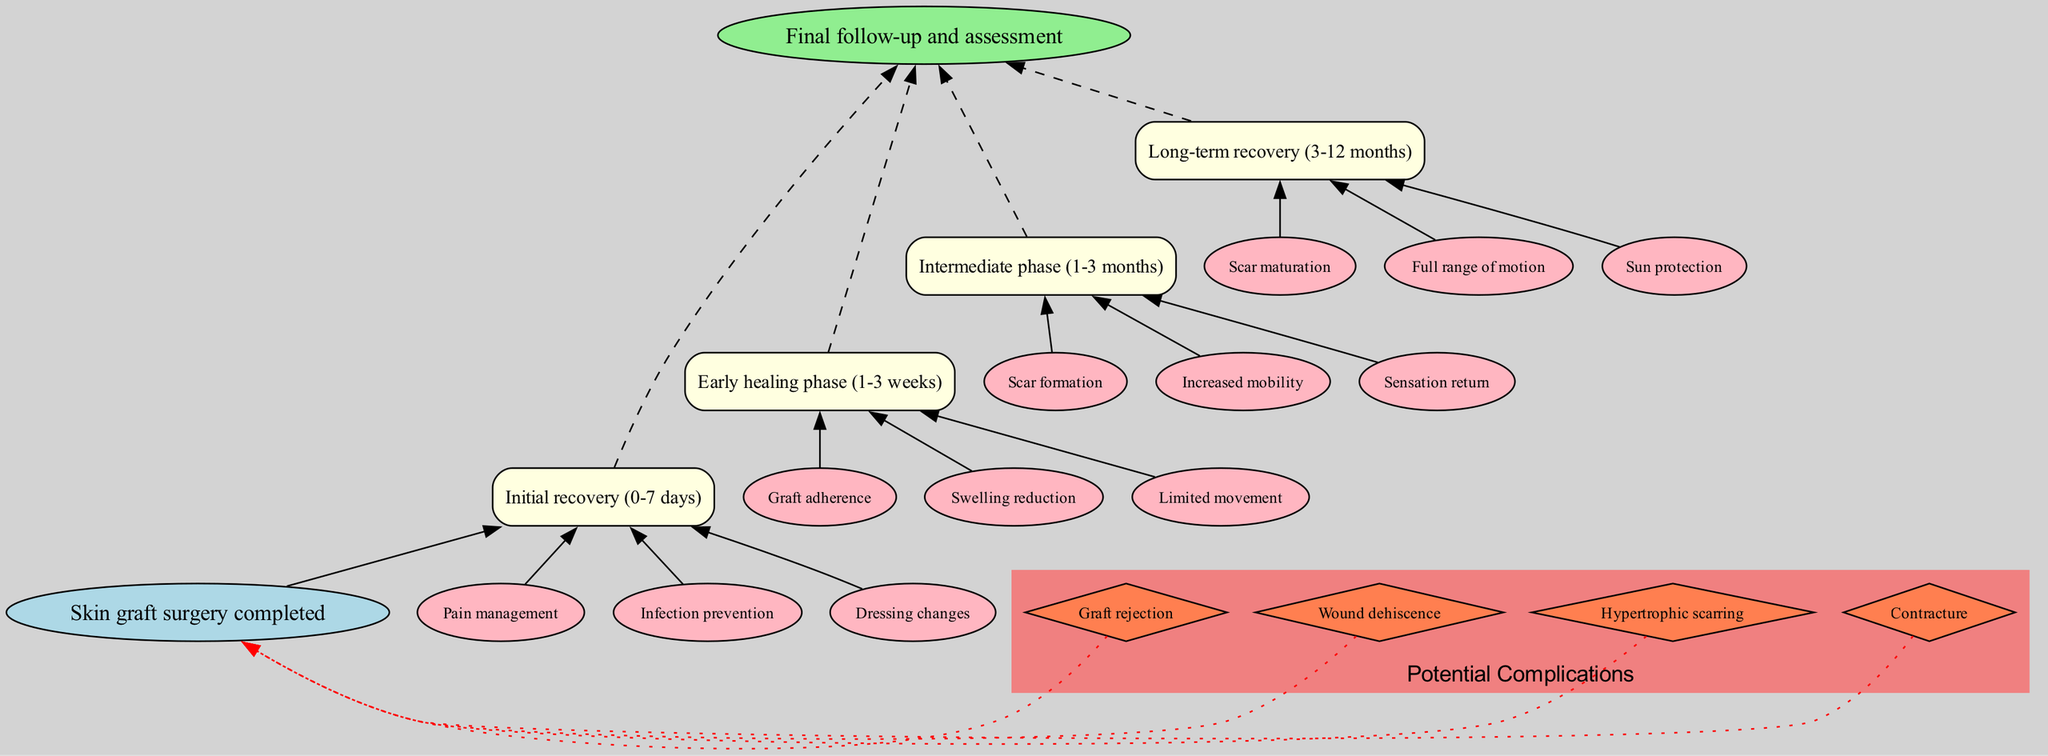What is the starting point of the recovery timeline? The diagram shows that the starting point is defined as "Skin graft surgery completed," which is represented at the top of the flow chart.
Answer: Skin graft surgery completed How many phases are there in the recovery timeline? By reviewing the diagram, it is identified that there are four distinct phases listed: Initial recovery, Early healing phase, Intermediate phase, and Long-term recovery.
Answer: 4 What occurs during the Early healing phase? The diagram specifies that during the Early healing phase (1-3 weeks), three key milestones are highlighted: Graft adherence, Swelling reduction, and Limited movement.
Answer: Graft adherence, Swelling reduction, Limited movement Which complication is associated with skin graft failure? The diagram indicates "Graft rejection" as one of the potential complications, which directly relates to the success of skin graft procedures.
Answer: Graft rejection During which phase does scar formation begin? From the diagram, it is clear that the Intermediate phase (1-3 months) is when "Scar formation" occurs, indicating the development of scar tissue post-surgery.
Answer: Intermediate phase (1-3 months) What is the last milestone before the final follow-up? The diagram states that "Full range of motion" is achieved during the Long-term recovery phase (3-12 months) as a key milestone prior to the final assessment.
Answer: Full range of motion How do complications relate to the starting point? The diagram shows that complications such as "Wound dehiscence" and "Hypertrophic scarring" link back to the starting point "Skin graft surgery completed," implying that these complications can occur immediately after surgery.
Answer: They are connected to "Skin graft surgery completed" What type of node represents the milestones during recovery? In the diagram, the milestones during recovery are represented as box shapes, which indicate distinct phases in the recovery process.
Answer: Box shapes Which complication specifically relates to issues with wound healing? The diagram highlights "Wound dehiscence" as a complication that directly pertains to problems associated with wound healing post-surgery.
Answer: Wound dehiscence 